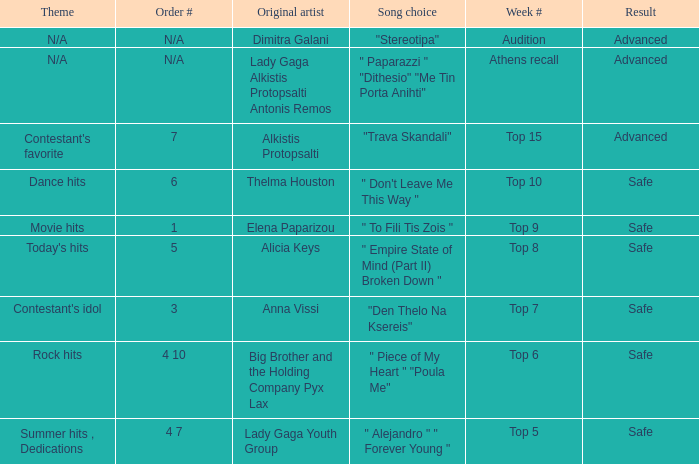What are all the order #s from the week "top 6"? 4 10. 